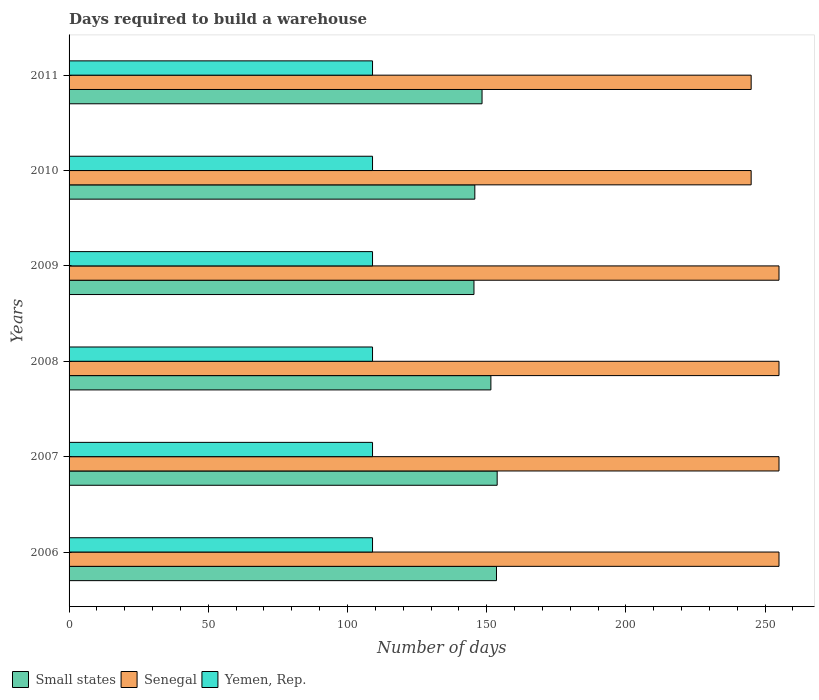How many different coloured bars are there?
Offer a very short reply. 3. Are the number of bars per tick equal to the number of legend labels?
Provide a short and direct response. Yes. Are the number of bars on each tick of the Y-axis equal?
Your response must be concise. Yes. How many bars are there on the 6th tick from the bottom?
Your answer should be very brief. 3. What is the label of the 1st group of bars from the top?
Make the answer very short. 2011. What is the days required to build a warehouse in in Senegal in 2011?
Provide a short and direct response. 245. Across all years, what is the maximum days required to build a warehouse in in Senegal?
Your response must be concise. 255. Across all years, what is the minimum days required to build a warehouse in in Yemen, Rep.?
Offer a terse response. 109. In which year was the days required to build a warehouse in in Small states maximum?
Ensure brevity in your answer.  2007. In which year was the days required to build a warehouse in in Small states minimum?
Your answer should be very brief. 2009. What is the total days required to build a warehouse in in Small states in the graph?
Offer a terse response. 898.33. What is the difference between the days required to build a warehouse in in Small states in 2007 and that in 2008?
Give a very brief answer. 2.26. What is the difference between the days required to build a warehouse in in Small states in 2006 and the days required to build a warehouse in in Yemen, Rep. in 2007?
Offer a very short reply. 44.53. What is the average days required to build a warehouse in in Senegal per year?
Ensure brevity in your answer.  251.67. In the year 2006, what is the difference between the days required to build a warehouse in in Small states and days required to build a warehouse in in Yemen, Rep.?
Offer a terse response. 44.53. In how many years, is the days required to build a warehouse in in Small states greater than 180 days?
Keep it short and to the point. 0. What is the ratio of the days required to build a warehouse in in Yemen, Rep. in 2006 to that in 2010?
Ensure brevity in your answer.  1. Is the difference between the days required to build a warehouse in in Small states in 2006 and 2008 greater than the difference between the days required to build a warehouse in in Yemen, Rep. in 2006 and 2008?
Your answer should be very brief. Yes. What is the difference between the highest and the lowest days required to build a warehouse in in Yemen, Rep.?
Make the answer very short. 0. Is the sum of the days required to build a warehouse in in Small states in 2006 and 2010 greater than the maximum days required to build a warehouse in in Yemen, Rep. across all years?
Ensure brevity in your answer.  Yes. What does the 1st bar from the top in 2007 represents?
Your response must be concise. Yemen, Rep. What does the 3rd bar from the bottom in 2008 represents?
Your response must be concise. Yemen, Rep. Is it the case that in every year, the sum of the days required to build a warehouse in in Small states and days required to build a warehouse in in Yemen, Rep. is greater than the days required to build a warehouse in in Senegal?
Make the answer very short. No. How many bars are there?
Give a very brief answer. 18. How many legend labels are there?
Offer a terse response. 3. What is the title of the graph?
Give a very brief answer. Days required to build a warehouse. Does "Botswana" appear as one of the legend labels in the graph?
Provide a short and direct response. No. What is the label or title of the X-axis?
Make the answer very short. Number of days. What is the Number of days of Small states in 2006?
Your response must be concise. 153.53. What is the Number of days in Senegal in 2006?
Your answer should be very brief. 255. What is the Number of days of Yemen, Rep. in 2006?
Provide a succinct answer. 109. What is the Number of days of Small states in 2007?
Offer a very short reply. 153.77. What is the Number of days of Senegal in 2007?
Provide a short and direct response. 255. What is the Number of days of Yemen, Rep. in 2007?
Provide a succinct answer. 109. What is the Number of days in Small states in 2008?
Offer a very short reply. 151.51. What is the Number of days of Senegal in 2008?
Your answer should be very brief. 255. What is the Number of days of Yemen, Rep. in 2008?
Your answer should be compact. 109. What is the Number of days of Small states in 2009?
Give a very brief answer. 145.44. What is the Number of days in Senegal in 2009?
Make the answer very short. 255. What is the Number of days of Yemen, Rep. in 2009?
Make the answer very short. 109. What is the Number of days in Small states in 2010?
Your answer should be compact. 145.74. What is the Number of days of Senegal in 2010?
Your answer should be very brief. 245. What is the Number of days of Yemen, Rep. in 2010?
Your response must be concise. 109. What is the Number of days of Small states in 2011?
Ensure brevity in your answer.  148.34. What is the Number of days in Senegal in 2011?
Provide a succinct answer. 245. What is the Number of days of Yemen, Rep. in 2011?
Ensure brevity in your answer.  109. Across all years, what is the maximum Number of days of Small states?
Ensure brevity in your answer.  153.77. Across all years, what is the maximum Number of days in Senegal?
Make the answer very short. 255. Across all years, what is the maximum Number of days in Yemen, Rep.?
Offer a terse response. 109. Across all years, what is the minimum Number of days in Small states?
Provide a short and direct response. 145.44. Across all years, what is the minimum Number of days of Senegal?
Keep it short and to the point. 245. Across all years, what is the minimum Number of days of Yemen, Rep.?
Provide a short and direct response. 109. What is the total Number of days of Small states in the graph?
Give a very brief answer. 898.33. What is the total Number of days in Senegal in the graph?
Provide a succinct answer. 1510. What is the total Number of days in Yemen, Rep. in the graph?
Your answer should be very brief. 654. What is the difference between the Number of days of Small states in 2006 and that in 2007?
Your answer should be compact. -0.24. What is the difference between the Number of days of Yemen, Rep. in 2006 and that in 2007?
Give a very brief answer. 0. What is the difference between the Number of days of Small states in 2006 and that in 2008?
Make the answer very short. 2.01. What is the difference between the Number of days of Senegal in 2006 and that in 2008?
Provide a short and direct response. 0. What is the difference between the Number of days in Small states in 2006 and that in 2009?
Your response must be concise. 8.09. What is the difference between the Number of days of Senegal in 2006 and that in 2009?
Offer a very short reply. 0. What is the difference between the Number of days in Small states in 2006 and that in 2010?
Keep it short and to the point. 7.78. What is the difference between the Number of days of Senegal in 2006 and that in 2010?
Your answer should be compact. 10. What is the difference between the Number of days in Small states in 2006 and that in 2011?
Provide a short and direct response. 5.19. What is the difference between the Number of days in Senegal in 2006 and that in 2011?
Ensure brevity in your answer.  10. What is the difference between the Number of days in Small states in 2007 and that in 2008?
Provide a succinct answer. 2.26. What is the difference between the Number of days of Senegal in 2007 and that in 2008?
Make the answer very short. 0. What is the difference between the Number of days of Small states in 2007 and that in 2009?
Make the answer very short. 8.33. What is the difference between the Number of days in Yemen, Rep. in 2007 and that in 2009?
Your answer should be compact. 0. What is the difference between the Number of days of Small states in 2007 and that in 2010?
Give a very brief answer. 8.03. What is the difference between the Number of days in Small states in 2007 and that in 2011?
Keep it short and to the point. 5.43. What is the difference between the Number of days of Small states in 2008 and that in 2009?
Ensure brevity in your answer.  6.08. What is the difference between the Number of days of Senegal in 2008 and that in 2009?
Make the answer very short. 0. What is the difference between the Number of days in Yemen, Rep. in 2008 and that in 2009?
Offer a terse response. 0. What is the difference between the Number of days of Small states in 2008 and that in 2010?
Provide a succinct answer. 5.77. What is the difference between the Number of days of Senegal in 2008 and that in 2010?
Offer a terse response. 10. What is the difference between the Number of days of Yemen, Rep. in 2008 and that in 2010?
Provide a short and direct response. 0. What is the difference between the Number of days of Small states in 2008 and that in 2011?
Provide a succinct answer. 3.18. What is the difference between the Number of days of Senegal in 2008 and that in 2011?
Your answer should be very brief. 10. What is the difference between the Number of days of Small states in 2009 and that in 2010?
Give a very brief answer. -0.31. What is the difference between the Number of days of Senegal in 2009 and that in 2010?
Offer a terse response. 10. What is the difference between the Number of days of Yemen, Rep. in 2009 and that in 2010?
Keep it short and to the point. 0. What is the difference between the Number of days of Small states in 2009 and that in 2011?
Offer a terse response. -2.9. What is the difference between the Number of days in Senegal in 2009 and that in 2011?
Provide a short and direct response. 10. What is the difference between the Number of days in Small states in 2010 and that in 2011?
Your response must be concise. -2.59. What is the difference between the Number of days of Senegal in 2010 and that in 2011?
Offer a terse response. 0. What is the difference between the Number of days in Yemen, Rep. in 2010 and that in 2011?
Your response must be concise. 0. What is the difference between the Number of days in Small states in 2006 and the Number of days in Senegal in 2007?
Your answer should be compact. -101.47. What is the difference between the Number of days in Small states in 2006 and the Number of days in Yemen, Rep. in 2007?
Provide a succinct answer. 44.53. What is the difference between the Number of days in Senegal in 2006 and the Number of days in Yemen, Rep. in 2007?
Your answer should be very brief. 146. What is the difference between the Number of days in Small states in 2006 and the Number of days in Senegal in 2008?
Provide a succinct answer. -101.47. What is the difference between the Number of days in Small states in 2006 and the Number of days in Yemen, Rep. in 2008?
Give a very brief answer. 44.53. What is the difference between the Number of days in Senegal in 2006 and the Number of days in Yemen, Rep. in 2008?
Provide a succinct answer. 146. What is the difference between the Number of days of Small states in 2006 and the Number of days of Senegal in 2009?
Provide a short and direct response. -101.47. What is the difference between the Number of days of Small states in 2006 and the Number of days of Yemen, Rep. in 2009?
Offer a terse response. 44.53. What is the difference between the Number of days in Senegal in 2006 and the Number of days in Yemen, Rep. in 2009?
Your answer should be very brief. 146. What is the difference between the Number of days of Small states in 2006 and the Number of days of Senegal in 2010?
Offer a terse response. -91.47. What is the difference between the Number of days in Small states in 2006 and the Number of days in Yemen, Rep. in 2010?
Provide a succinct answer. 44.53. What is the difference between the Number of days of Senegal in 2006 and the Number of days of Yemen, Rep. in 2010?
Ensure brevity in your answer.  146. What is the difference between the Number of days of Small states in 2006 and the Number of days of Senegal in 2011?
Your response must be concise. -91.47. What is the difference between the Number of days in Small states in 2006 and the Number of days in Yemen, Rep. in 2011?
Provide a short and direct response. 44.53. What is the difference between the Number of days in Senegal in 2006 and the Number of days in Yemen, Rep. in 2011?
Make the answer very short. 146. What is the difference between the Number of days of Small states in 2007 and the Number of days of Senegal in 2008?
Make the answer very short. -101.23. What is the difference between the Number of days of Small states in 2007 and the Number of days of Yemen, Rep. in 2008?
Your answer should be compact. 44.77. What is the difference between the Number of days in Senegal in 2007 and the Number of days in Yemen, Rep. in 2008?
Your answer should be compact. 146. What is the difference between the Number of days in Small states in 2007 and the Number of days in Senegal in 2009?
Your answer should be very brief. -101.23. What is the difference between the Number of days in Small states in 2007 and the Number of days in Yemen, Rep. in 2009?
Provide a short and direct response. 44.77. What is the difference between the Number of days of Senegal in 2007 and the Number of days of Yemen, Rep. in 2009?
Keep it short and to the point. 146. What is the difference between the Number of days of Small states in 2007 and the Number of days of Senegal in 2010?
Ensure brevity in your answer.  -91.23. What is the difference between the Number of days in Small states in 2007 and the Number of days in Yemen, Rep. in 2010?
Provide a succinct answer. 44.77. What is the difference between the Number of days of Senegal in 2007 and the Number of days of Yemen, Rep. in 2010?
Ensure brevity in your answer.  146. What is the difference between the Number of days of Small states in 2007 and the Number of days of Senegal in 2011?
Your response must be concise. -91.23. What is the difference between the Number of days of Small states in 2007 and the Number of days of Yemen, Rep. in 2011?
Offer a very short reply. 44.77. What is the difference between the Number of days of Senegal in 2007 and the Number of days of Yemen, Rep. in 2011?
Your response must be concise. 146. What is the difference between the Number of days in Small states in 2008 and the Number of days in Senegal in 2009?
Your answer should be compact. -103.49. What is the difference between the Number of days of Small states in 2008 and the Number of days of Yemen, Rep. in 2009?
Offer a very short reply. 42.51. What is the difference between the Number of days in Senegal in 2008 and the Number of days in Yemen, Rep. in 2009?
Your response must be concise. 146. What is the difference between the Number of days of Small states in 2008 and the Number of days of Senegal in 2010?
Offer a terse response. -93.49. What is the difference between the Number of days of Small states in 2008 and the Number of days of Yemen, Rep. in 2010?
Your response must be concise. 42.51. What is the difference between the Number of days in Senegal in 2008 and the Number of days in Yemen, Rep. in 2010?
Make the answer very short. 146. What is the difference between the Number of days of Small states in 2008 and the Number of days of Senegal in 2011?
Keep it short and to the point. -93.49. What is the difference between the Number of days of Small states in 2008 and the Number of days of Yemen, Rep. in 2011?
Give a very brief answer. 42.51. What is the difference between the Number of days of Senegal in 2008 and the Number of days of Yemen, Rep. in 2011?
Keep it short and to the point. 146. What is the difference between the Number of days in Small states in 2009 and the Number of days in Senegal in 2010?
Make the answer very short. -99.56. What is the difference between the Number of days in Small states in 2009 and the Number of days in Yemen, Rep. in 2010?
Give a very brief answer. 36.44. What is the difference between the Number of days of Senegal in 2009 and the Number of days of Yemen, Rep. in 2010?
Provide a short and direct response. 146. What is the difference between the Number of days in Small states in 2009 and the Number of days in Senegal in 2011?
Keep it short and to the point. -99.56. What is the difference between the Number of days in Small states in 2009 and the Number of days in Yemen, Rep. in 2011?
Your answer should be compact. 36.44. What is the difference between the Number of days of Senegal in 2009 and the Number of days of Yemen, Rep. in 2011?
Provide a succinct answer. 146. What is the difference between the Number of days of Small states in 2010 and the Number of days of Senegal in 2011?
Make the answer very short. -99.26. What is the difference between the Number of days in Small states in 2010 and the Number of days in Yemen, Rep. in 2011?
Ensure brevity in your answer.  36.74. What is the difference between the Number of days in Senegal in 2010 and the Number of days in Yemen, Rep. in 2011?
Offer a terse response. 136. What is the average Number of days of Small states per year?
Your response must be concise. 149.72. What is the average Number of days of Senegal per year?
Ensure brevity in your answer.  251.67. What is the average Number of days of Yemen, Rep. per year?
Your response must be concise. 109. In the year 2006, what is the difference between the Number of days in Small states and Number of days in Senegal?
Make the answer very short. -101.47. In the year 2006, what is the difference between the Number of days in Small states and Number of days in Yemen, Rep.?
Provide a short and direct response. 44.53. In the year 2006, what is the difference between the Number of days in Senegal and Number of days in Yemen, Rep.?
Your answer should be very brief. 146. In the year 2007, what is the difference between the Number of days of Small states and Number of days of Senegal?
Offer a very short reply. -101.23. In the year 2007, what is the difference between the Number of days of Small states and Number of days of Yemen, Rep.?
Give a very brief answer. 44.77. In the year 2007, what is the difference between the Number of days of Senegal and Number of days of Yemen, Rep.?
Offer a terse response. 146. In the year 2008, what is the difference between the Number of days of Small states and Number of days of Senegal?
Ensure brevity in your answer.  -103.49. In the year 2008, what is the difference between the Number of days in Small states and Number of days in Yemen, Rep.?
Keep it short and to the point. 42.51. In the year 2008, what is the difference between the Number of days of Senegal and Number of days of Yemen, Rep.?
Your answer should be compact. 146. In the year 2009, what is the difference between the Number of days in Small states and Number of days in Senegal?
Provide a short and direct response. -109.56. In the year 2009, what is the difference between the Number of days in Small states and Number of days in Yemen, Rep.?
Provide a succinct answer. 36.44. In the year 2009, what is the difference between the Number of days in Senegal and Number of days in Yemen, Rep.?
Your answer should be very brief. 146. In the year 2010, what is the difference between the Number of days of Small states and Number of days of Senegal?
Offer a very short reply. -99.26. In the year 2010, what is the difference between the Number of days of Small states and Number of days of Yemen, Rep.?
Provide a succinct answer. 36.74. In the year 2010, what is the difference between the Number of days in Senegal and Number of days in Yemen, Rep.?
Make the answer very short. 136. In the year 2011, what is the difference between the Number of days of Small states and Number of days of Senegal?
Provide a succinct answer. -96.66. In the year 2011, what is the difference between the Number of days in Small states and Number of days in Yemen, Rep.?
Ensure brevity in your answer.  39.34. In the year 2011, what is the difference between the Number of days of Senegal and Number of days of Yemen, Rep.?
Your answer should be compact. 136. What is the ratio of the Number of days in Small states in 2006 to that in 2007?
Give a very brief answer. 1. What is the ratio of the Number of days in Small states in 2006 to that in 2008?
Offer a terse response. 1.01. What is the ratio of the Number of days in Small states in 2006 to that in 2009?
Make the answer very short. 1.06. What is the ratio of the Number of days in Yemen, Rep. in 2006 to that in 2009?
Give a very brief answer. 1. What is the ratio of the Number of days in Small states in 2006 to that in 2010?
Your answer should be very brief. 1.05. What is the ratio of the Number of days of Senegal in 2006 to that in 2010?
Ensure brevity in your answer.  1.04. What is the ratio of the Number of days of Yemen, Rep. in 2006 to that in 2010?
Your answer should be very brief. 1. What is the ratio of the Number of days in Small states in 2006 to that in 2011?
Provide a succinct answer. 1.03. What is the ratio of the Number of days in Senegal in 2006 to that in 2011?
Provide a succinct answer. 1.04. What is the ratio of the Number of days of Yemen, Rep. in 2006 to that in 2011?
Give a very brief answer. 1. What is the ratio of the Number of days of Small states in 2007 to that in 2008?
Your answer should be very brief. 1.01. What is the ratio of the Number of days of Small states in 2007 to that in 2009?
Ensure brevity in your answer.  1.06. What is the ratio of the Number of days in Senegal in 2007 to that in 2009?
Offer a very short reply. 1. What is the ratio of the Number of days in Small states in 2007 to that in 2010?
Provide a short and direct response. 1.06. What is the ratio of the Number of days of Senegal in 2007 to that in 2010?
Your response must be concise. 1.04. What is the ratio of the Number of days in Small states in 2007 to that in 2011?
Provide a short and direct response. 1.04. What is the ratio of the Number of days of Senegal in 2007 to that in 2011?
Your answer should be very brief. 1.04. What is the ratio of the Number of days of Yemen, Rep. in 2007 to that in 2011?
Ensure brevity in your answer.  1. What is the ratio of the Number of days of Small states in 2008 to that in 2009?
Ensure brevity in your answer.  1.04. What is the ratio of the Number of days in Senegal in 2008 to that in 2009?
Your response must be concise. 1. What is the ratio of the Number of days of Small states in 2008 to that in 2010?
Give a very brief answer. 1.04. What is the ratio of the Number of days of Senegal in 2008 to that in 2010?
Make the answer very short. 1.04. What is the ratio of the Number of days of Small states in 2008 to that in 2011?
Provide a succinct answer. 1.02. What is the ratio of the Number of days of Senegal in 2008 to that in 2011?
Give a very brief answer. 1.04. What is the ratio of the Number of days in Yemen, Rep. in 2008 to that in 2011?
Make the answer very short. 1. What is the ratio of the Number of days in Senegal in 2009 to that in 2010?
Provide a short and direct response. 1.04. What is the ratio of the Number of days of Yemen, Rep. in 2009 to that in 2010?
Offer a very short reply. 1. What is the ratio of the Number of days of Small states in 2009 to that in 2011?
Your answer should be compact. 0.98. What is the ratio of the Number of days in Senegal in 2009 to that in 2011?
Offer a terse response. 1.04. What is the ratio of the Number of days in Yemen, Rep. in 2009 to that in 2011?
Make the answer very short. 1. What is the ratio of the Number of days of Small states in 2010 to that in 2011?
Provide a short and direct response. 0.98. What is the difference between the highest and the second highest Number of days of Small states?
Keep it short and to the point. 0.24. What is the difference between the highest and the second highest Number of days of Senegal?
Offer a very short reply. 0. What is the difference between the highest and the second highest Number of days of Yemen, Rep.?
Ensure brevity in your answer.  0. What is the difference between the highest and the lowest Number of days of Small states?
Your response must be concise. 8.33. What is the difference between the highest and the lowest Number of days of Yemen, Rep.?
Provide a short and direct response. 0. 